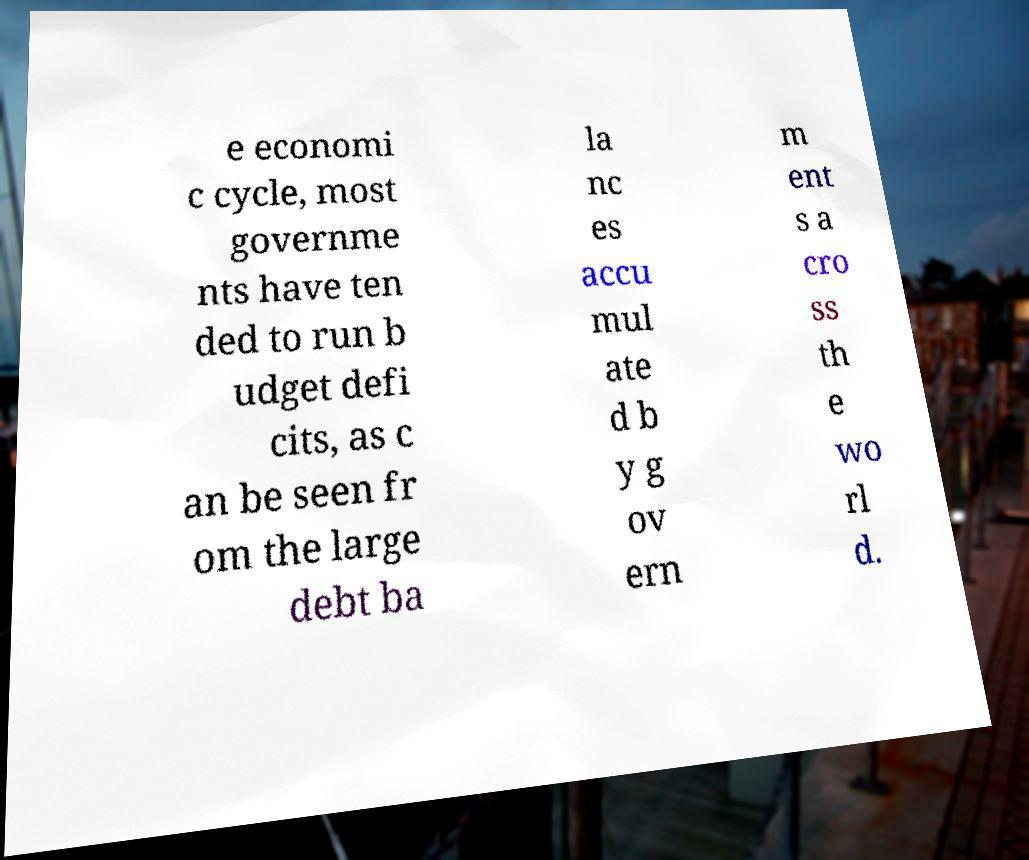Can you accurately transcribe the text from the provided image for me? e economi c cycle, most governme nts have ten ded to run b udget defi cits, as c an be seen fr om the large debt ba la nc es accu mul ate d b y g ov ern m ent s a cro ss th e wo rl d. 